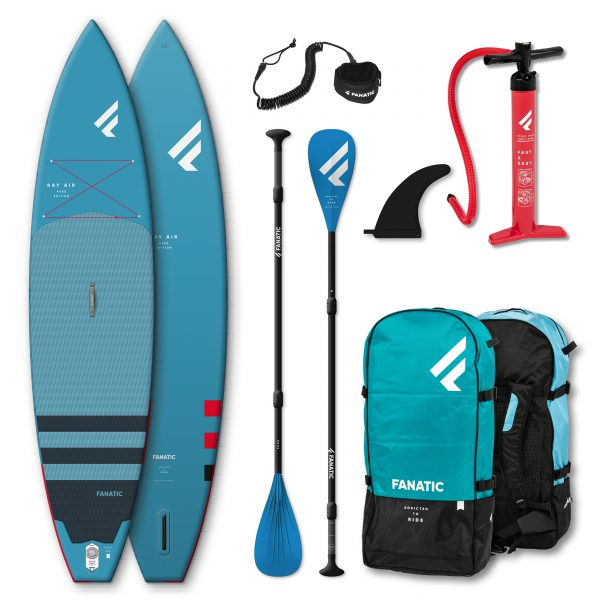Considering the items provided with the stand-up paddleboards, what essential safety or navigation equipment that is commonly associated with paddleboarding seems to be missing from this collection? Based on the image, it looks like essential safety equipment, such as a personal flotation device (PFD), is missing from the collection. A PFD is crucial for safety while paddleboarding to prevent drowning in case of an accident. Additionally, navigation tools like lights or a compass are also absent, which are important for ensuring safe travel, particularly in low-light conditions or unfamiliar waters. 